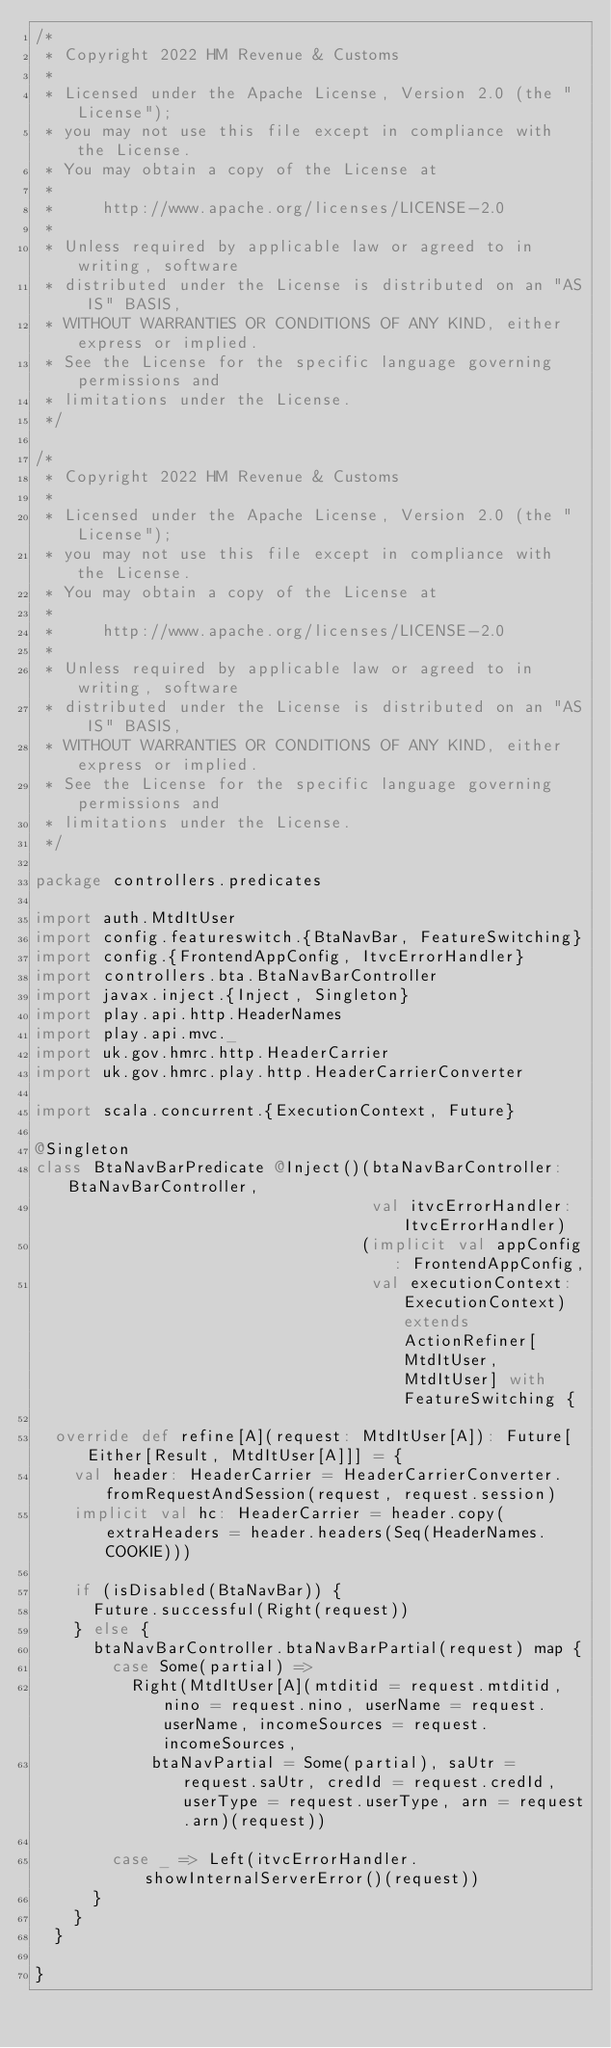Convert code to text. <code><loc_0><loc_0><loc_500><loc_500><_Scala_>/*
 * Copyright 2022 HM Revenue & Customs
 *
 * Licensed under the Apache License, Version 2.0 (the "License");
 * you may not use this file except in compliance with the License.
 * You may obtain a copy of the License at
 *
 *     http://www.apache.org/licenses/LICENSE-2.0
 *
 * Unless required by applicable law or agreed to in writing, software
 * distributed under the License is distributed on an "AS IS" BASIS,
 * WITHOUT WARRANTIES OR CONDITIONS OF ANY KIND, either express or implied.
 * See the License for the specific language governing permissions and
 * limitations under the License.
 */

/*
 * Copyright 2022 HM Revenue & Customs
 *
 * Licensed under the Apache License, Version 2.0 (the "License");
 * you may not use this file except in compliance with the License.
 * You may obtain a copy of the License at
 *
 *     http://www.apache.org/licenses/LICENSE-2.0
 *
 * Unless required by applicable law or agreed to in writing, software
 * distributed under the License is distributed on an "AS IS" BASIS,
 * WITHOUT WARRANTIES OR CONDITIONS OF ANY KIND, either express or implied.
 * See the License for the specific language governing permissions and
 * limitations under the License.
 */

package controllers.predicates

import auth.MtdItUser
import config.featureswitch.{BtaNavBar, FeatureSwitching}
import config.{FrontendAppConfig, ItvcErrorHandler}
import controllers.bta.BtaNavBarController
import javax.inject.{Inject, Singleton}
import play.api.http.HeaderNames
import play.api.mvc._
import uk.gov.hmrc.http.HeaderCarrier
import uk.gov.hmrc.play.http.HeaderCarrierConverter

import scala.concurrent.{ExecutionContext, Future}

@Singleton
class BtaNavBarPredicate @Inject()(btaNavBarController: BtaNavBarController,
                                   val itvcErrorHandler: ItvcErrorHandler)
                                  (implicit val appConfig: FrontendAppConfig,
                                   val executionContext: ExecutionContext) extends ActionRefiner[MtdItUser, MtdItUser] with FeatureSwitching {

  override def refine[A](request: MtdItUser[A]): Future[Either[Result, MtdItUser[A]]] = {
    val header: HeaderCarrier = HeaderCarrierConverter.fromRequestAndSession(request, request.session)
    implicit val hc: HeaderCarrier = header.copy(extraHeaders = header.headers(Seq(HeaderNames.COOKIE)))

    if (isDisabled(BtaNavBar)) {
      Future.successful(Right(request))
    } else {
      btaNavBarController.btaNavBarPartial(request) map {
        case Some(partial) =>
          Right(MtdItUser[A](mtditid = request.mtditid, nino = request.nino, userName = request.userName, incomeSources = request.incomeSources,
            btaNavPartial = Some(partial), saUtr = request.saUtr, credId = request.credId, userType = request.userType, arn = request.arn)(request))

        case _ => Left(itvcErrorHandler.showInternalServerError()(request))
      }
    }
  }

}
</code> 